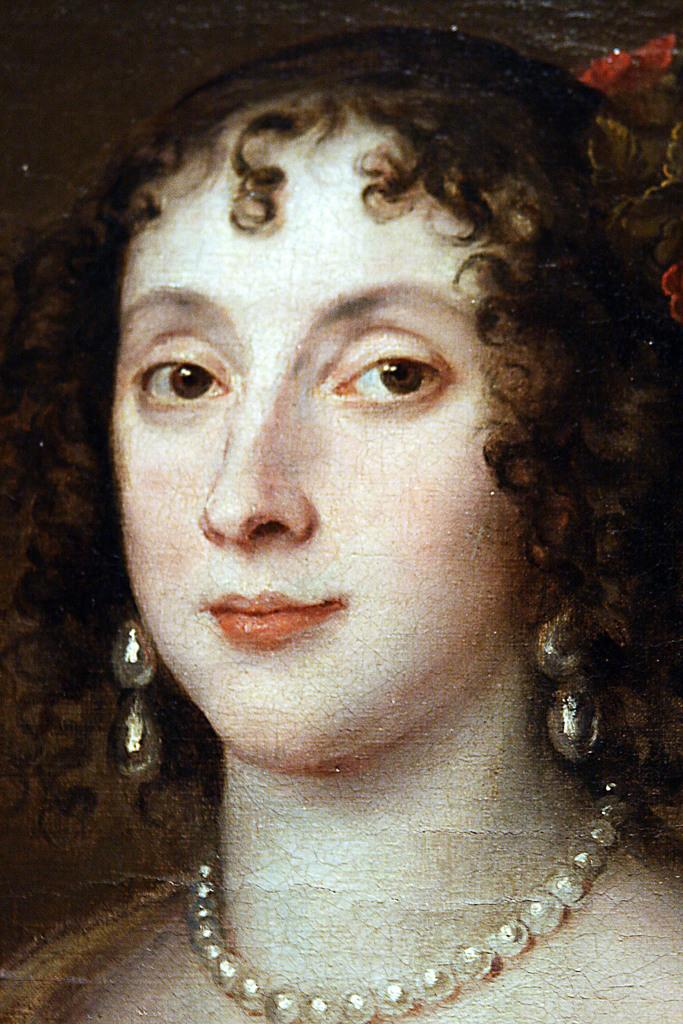What is the main subject of the painting in the image? The main subject of the painting in the image is a woman. How many teeth can be seen in the woman's smile in the painting? The painting does not show the woman's teeth, so it is not possible to determine the number of teeth in her smile. 